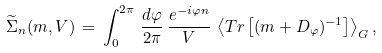<formula> <loc_0><loc_0><loc_500><loc_500>\widetilde { \Sigma } _ { n } ( m , V ) \, = \, \int _ { 0 } ^ { 2 \pi } \, \frac { d \varphi } { 2 \pi } \, \frac { e ^ { - i \varphi n } } { V } \, \left \langle T r \left [ ( m + D _ { \varphi } ) ^ { - 1 } \right ] \right \rangle _ { G } ,</formula> 